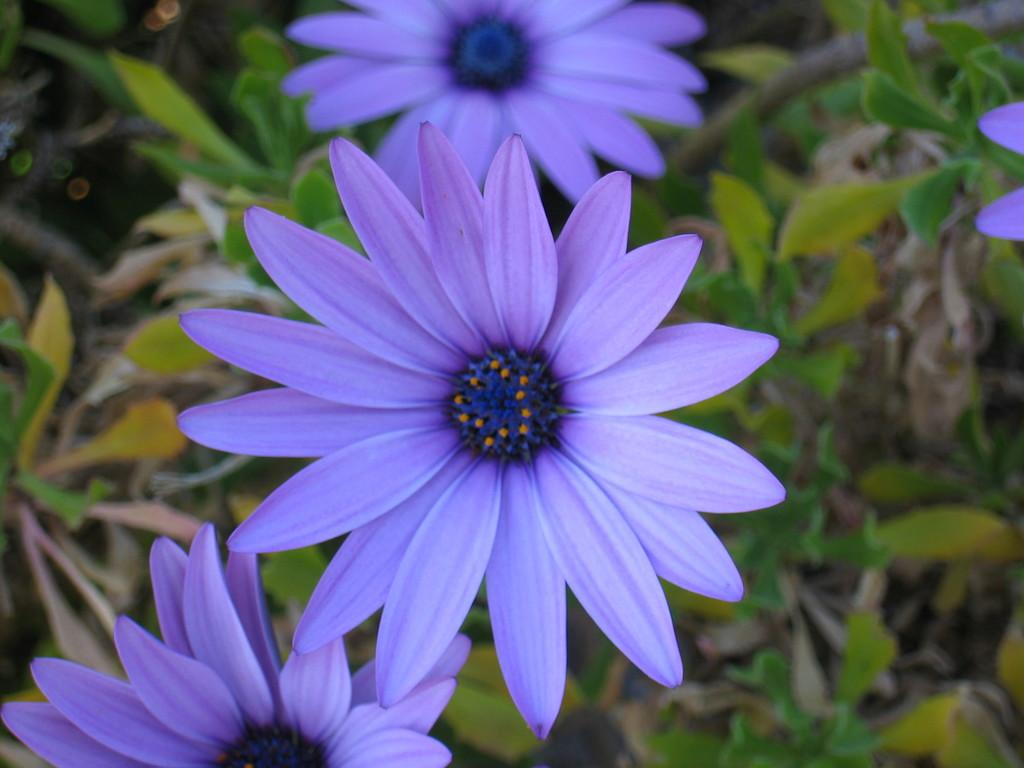What type of living organisms can be seen in the image? There are flowers in the image. Can you describe the location of the flowers in the image? The flowers are near plants. Where is the playground located in the image? There is no playground present in the image. What type of pest can be seen interacting with the flowers in the image? There is no pest interacting with the flowers in the image. 